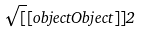Convert formula to latex. <formula><loc_0><loc_0><loc_500><loc_500>\sqrt { [ } [ o b j e c t O b j e c t ] ] { 2 }</formula> 